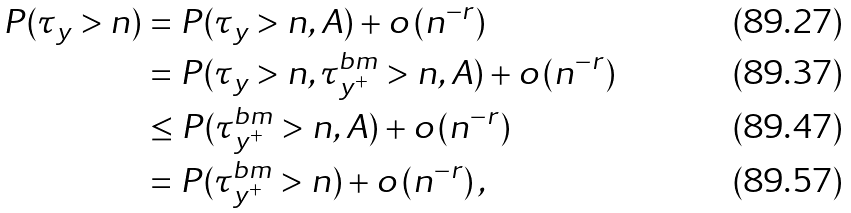Convert formula to latex. <formula><loc_0><loc_0><loc_500><loc_500>P ( \tau _ { y } > n ) & = P ( \tau _ { y } > n , A ) + o \left ( n ^ { - r } \right ) \\ & = P ( \tau _ { y } > n , \tau ^ { b m } _ { y ^ { + } } > n , A ) + o \left ( n ^ { - r } \right ) \\ & \leq P ( \tau ^ { b m } _ { y ^ { + } } > n , A ) + o \left ( n ^ { - r } \right ) \\ & = P ( \tau ^ { b m } _ { y ^ { + } } > n ) + o \left ( n ^ { - r } \right ) ,</formula> 